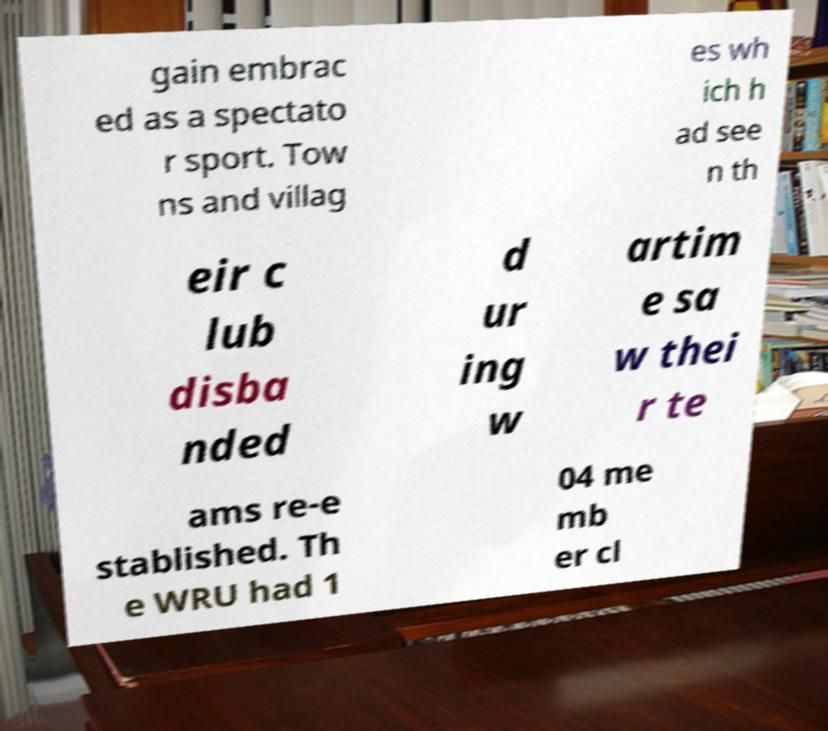There's text embedded in this image that I need extracted. Can you transcribe it verbatim? gain embrac ed as a spectato r sport. Tow ns and villag es wh ich h ad see n th eir c lub disba nded d ur ing w artim e sa w thei r te ams re-e stablished. Th e WRU had 1 04 me mb er cl 